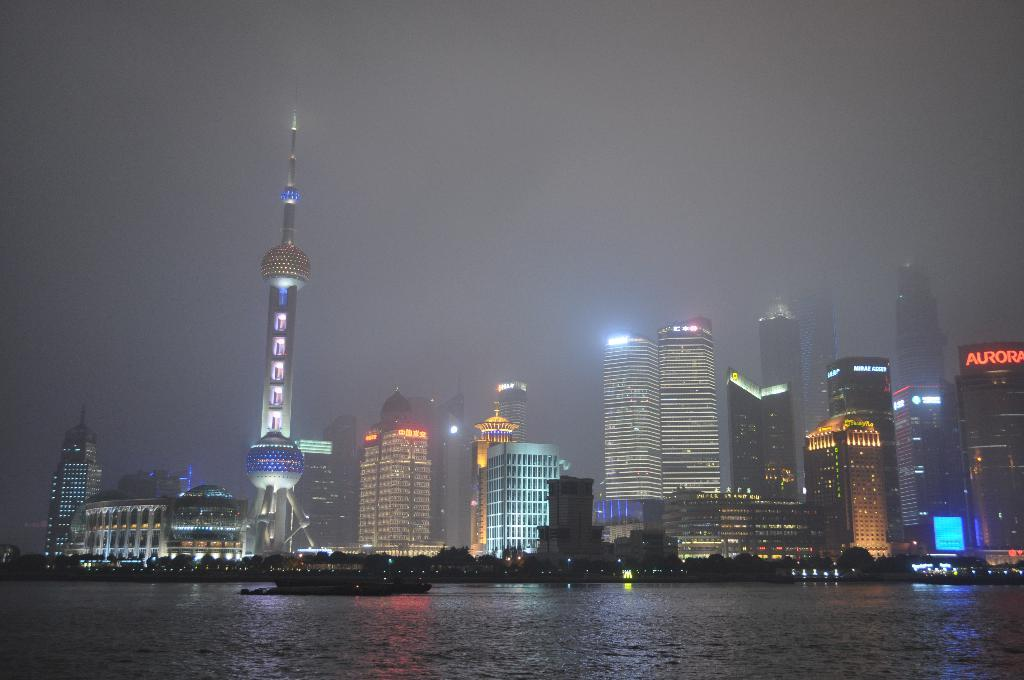What is the main subject of the picture? The main subject of the picture is a ship. What can be seen in the water in the picture? There is no specific detail about the water in the picture, but it is mentioned that there is water present. What is visible in the background of the picture? There are buildings and a dark sky visible in the background of the picture. How does the ship attack the buildings in the picture? There is no indication in the picture that the ship is attacking the buildings; it is simply present in the water. Can you describe the effect of the ship touching the water in the picture? There is no specific detail about the ship touching the water in the picture, so it is not possible to describe any effect. 